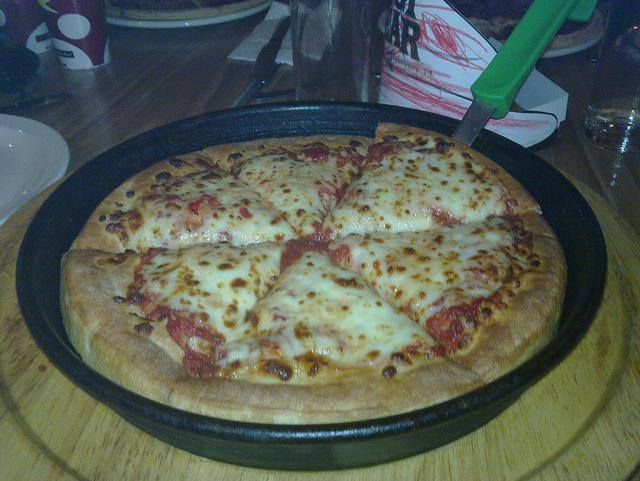Is the pizza still in the pan?
Quick response, please. Yes. Is this a deep dish pizza?
Keep it brief. Yes. How many slices of pizza are there?
Write a very short answer. 6. Is this pizza sliced normally?
Quick response, please. Yes. What is the number on the table?
Short answer required. 0. What is the pizza on?
Keep it brief. Pan. Which fruit is in the 3rd row of this platter?
Quick response, please. Tomato. What kind of toppings are on the pizza?
Keep it brief. Cheese. Is the food ready?
Be succinct. Yes. What kind of pizza is that?
Keep it brief. Cheese. 